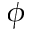Convert formula to latex. <formula><loc_0><loc_0><loc_500><loc_500>\phi</formula> 